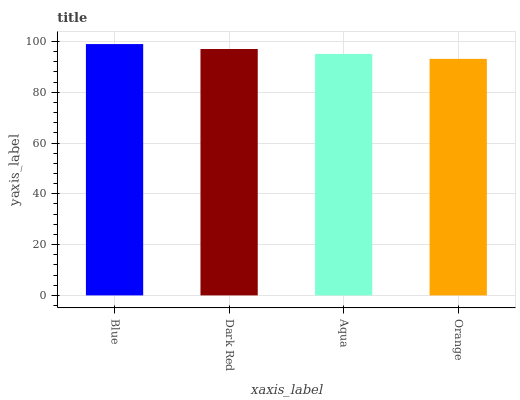Is Orange the minimum?
Answer yes or no. Yes. Is Blue the maximum?
Answer yes or no. Yes. Is Dark Red the minimum?
Answer yes or no. No. Is Dark Red the maximum?
Answer yes or no. No. Is Blue greater than Dark Red?
Answer yes or no. Yes. Is Dark Red less than Blue?
Answer yes or no. Yes. Is Dark Red greater than Blue?
Answer yes or no. No. Is Blue less than Dark Red?
Answer yes or no. No. Is Dark Red the high median?
Answer yes or no. Yes. Is Aqua the low median?
Answer yes or no. Yes. Is Blue the high median?
Answer yes or no. No. Is Blue the low median?
Answer yes or no. No. 